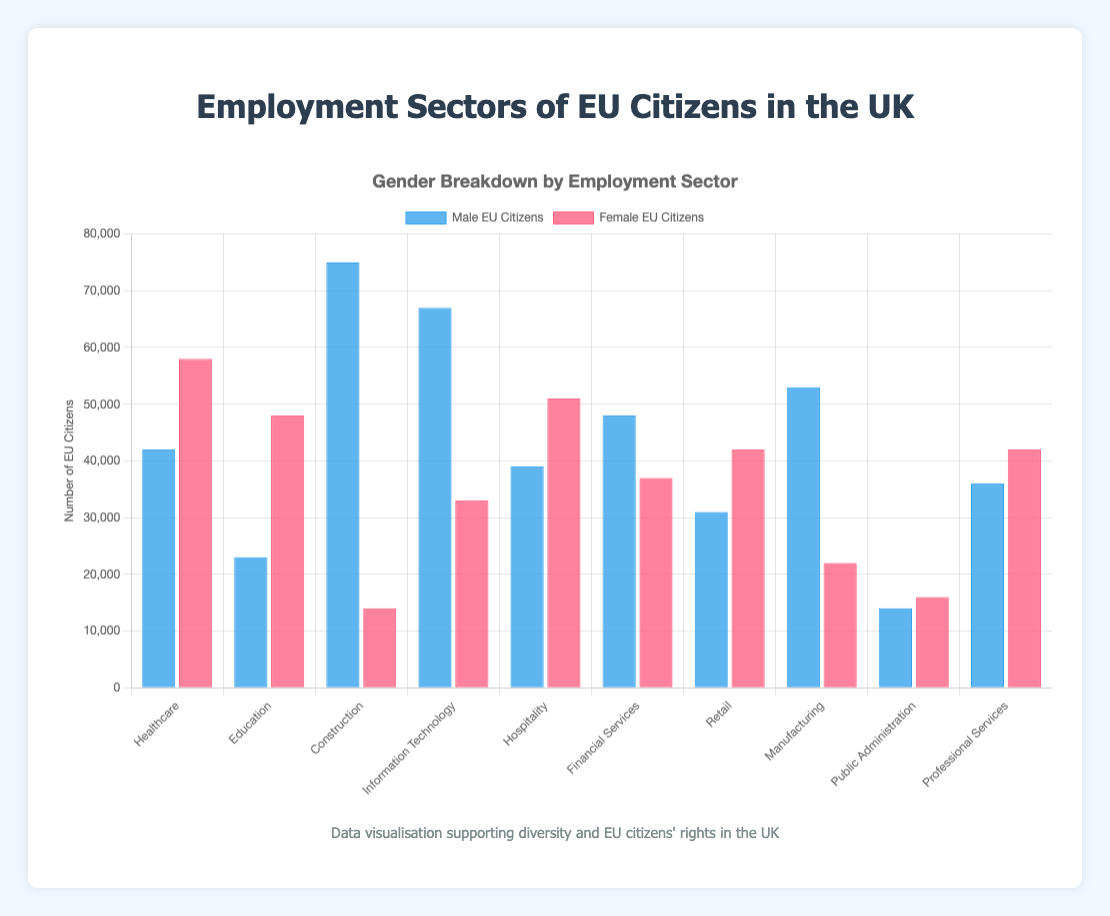Which sector has the highest number of male EU citizens employed and how many are employed there? The sector with the highest number of male EU citizens employed can be identified by looking at the tallest blue bar. The tallest blue bar corresponds to the Construction sector, with 75,000 male EU citizens.
Answer: Construction, 75,000 Which sector has the highest number of female EU citizens employed and how many are employed there? The sector with the highest number of female EU citizens employed can be identified by looking at the tallest red bar. The tallest red bar corresponds to the Healthcare sector, with 58,000 female EU citizens.
Answer: Healthcare, 58,000 What is the total number of EU citizens (both male and female) employed in the Information Technology sector? The total number of EU citizens in Information Technology can be calculated by adding the number of male and female EU citizens employed in this sector. The chart shows 67,000 male and 33,000 female EU citizens, so the total is 67,000 + 33,000 = 100,000.
Answer: 100,000 How many more male EU citizens are there than female EU citizens in the Construction sector? To find the difference, subtract the number of female EU citizens from the number of male EU citizens in the Construction sector. The chart shows 75,000 male and 14,000 female, so the difference is 75,000 - 14,000 = 61,000.
Answer: 61,000 Which sector has a nearly equal number of male and female EU citizens employed, and what are those numbers? This can be identified by looking for bars that are of nearly the same height in both blue and red. Public Administration has almost identical numbers, with 14,000 male and 16,000 female EU citizens.
Answer: Public Administration, 14,000 male, 16,000 female What is the average number of female EU citizens employed across all sectors? To calculate the average, sum the number of female EU citizens in all sectors and divide by the number of sectors. The numbers are 58,000, 48,000, 14,000, 33,000, 51,000, 37,000, 42,000, 22,000, 16,000, 42,000. Total = 363,000. Average = 363,000 / 10 = 36,300.
Answer: 36,300 In which two sectors do male EU citizens outnumber female EU citizens by the largest margin? Compare the difference in numbers between male and female in each sector. The sectors with the largest margins are Construction (75,000 - 14,000 = 61,000) and Information Technology (67,000 - 33,000 = 34,000).
Answer: Construction and Information Technology Which sectors have more female EU citizens employed than male EU citizens? Identify the sectors where the red bar (female) is taller than the blue bar (male). These sectors are Healthcare, Education, Hospitality, Retail, and Professional Services.
Answer: Healthcare, Education, Hospitality, Retail, Professional Services How does the employment of male and female EU citizens in the Financial Services sector compare? Compare the height of the blue and red bars for Financial Services. There are 48,000 male and 37,000 female EU citizens employed, meaning there are more males than females.
Answer: More males than females, 48,000 males vs. 37,000 females 